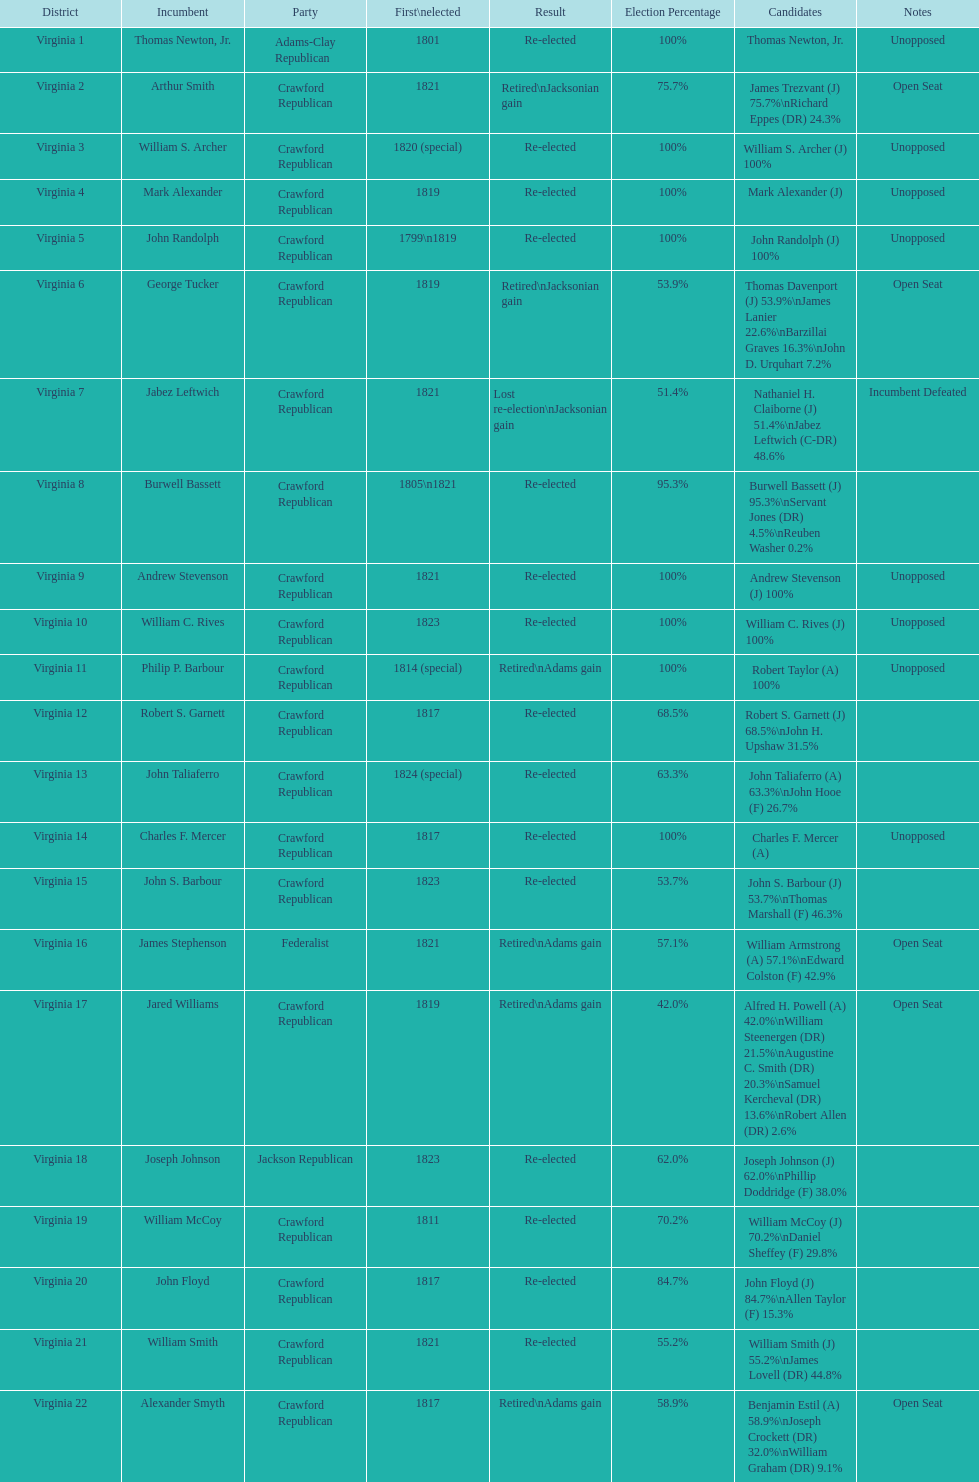Name the only candidate that was first elected in 1811. William McCoy. 